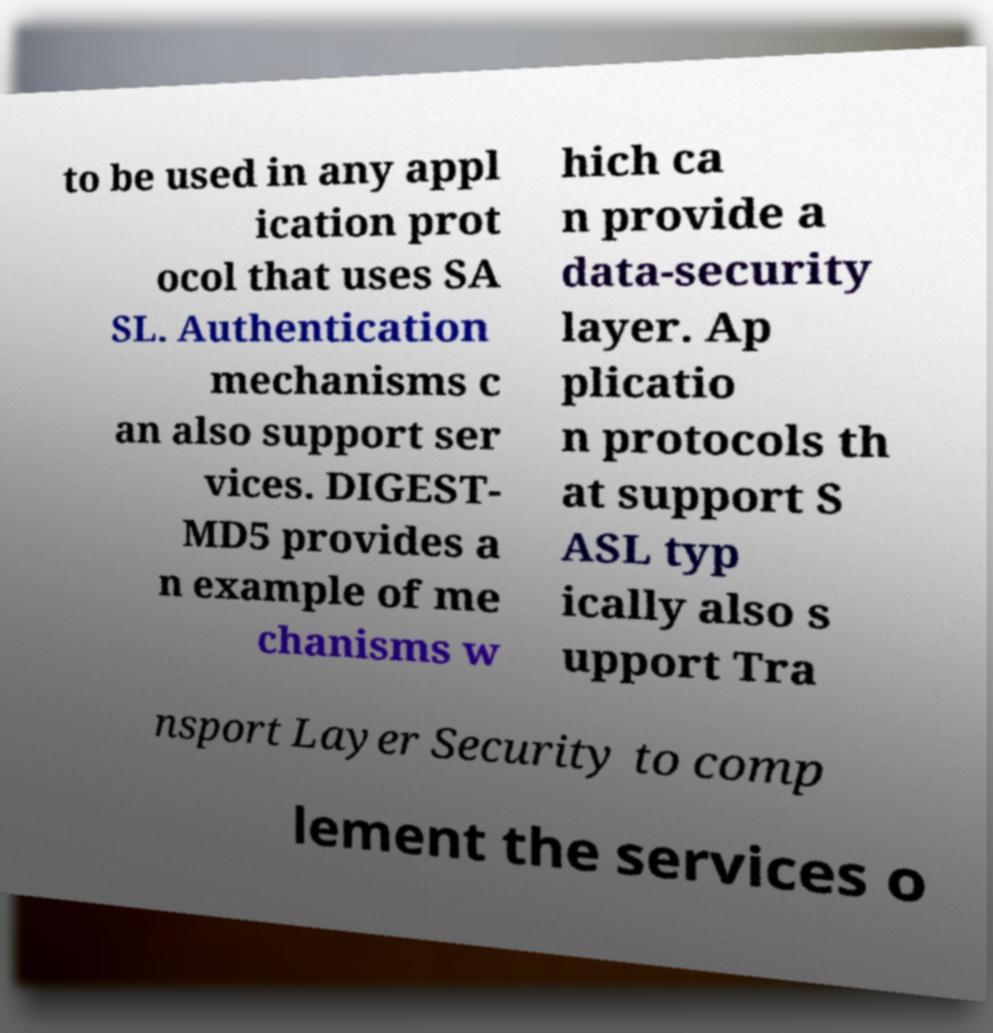Please read and relay the text visible in this image. What does it say? to be used in any appl ication prot ocol that uses SA SL. Authentication mechanisms c an also support ser vices. DIGEST- MD5 provides a n example of me chanisms w hich ca n provide a data-security layer. Ap plicatio n protocols th at support S ASL typ ically also s upport Tra nsport Layer Security to comp lement the services o 